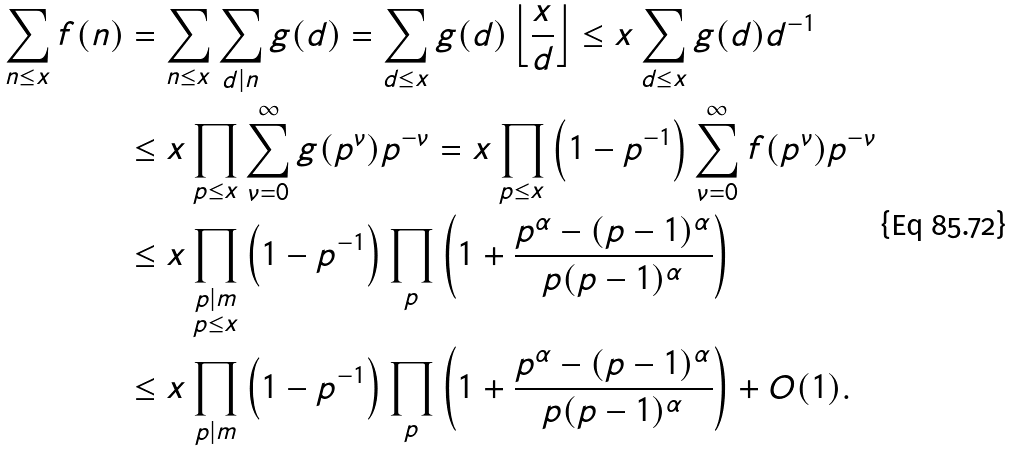<formula> <loc_0><loc_0><loc_500><loc_500>\sum _ { n \leq x } f ( n ) & = \sum _ { n \leq x } \sum _ { d | n } g ( d ) = \sum _ { d \leq x } g ( d ) \left \lfloor \frac { x } { d } \right \rfloor \leq x \sum _ { d \leq x } g ( d ) d ^ { - 1 } \\ & \leq x \prod _ { p \leq x } \sum _ { \nu = 0 } ^ { \infty } g ( p ^ { \nu } ) p ^ { - \nu } = x \prod _ { p \leq x } \left ( 1 - p ^ { - 1 } \right ) \sum _ { \nu = 0 } ^ { \infty } f ( p ^ { \nu } ) p ^ { - \nu } \\ & \leq x \prod _ { \substack { p | m \\ p \leq x } } \left ( 1 - p ^ { - 1 } \right ) \prod _ { p } \left ( 1 + \frac { p ^ { \alpha } - ( p - 1 ) ^ { \alpha } } { p ( p - 1 ) ^ { \alpha } } \right ) \\ & \leq x \prod _ { p | m } \left ( 1 - p ^ { - 1 } \right ) \prod _ { p } \left ( 1 + \frac { p ^ { \alpha } - ( p - 1 ) ^ { \alpha } } { p ( p - 1 ) ^ { \alpha } } \right ) + O ( 1 ) .</formula> 